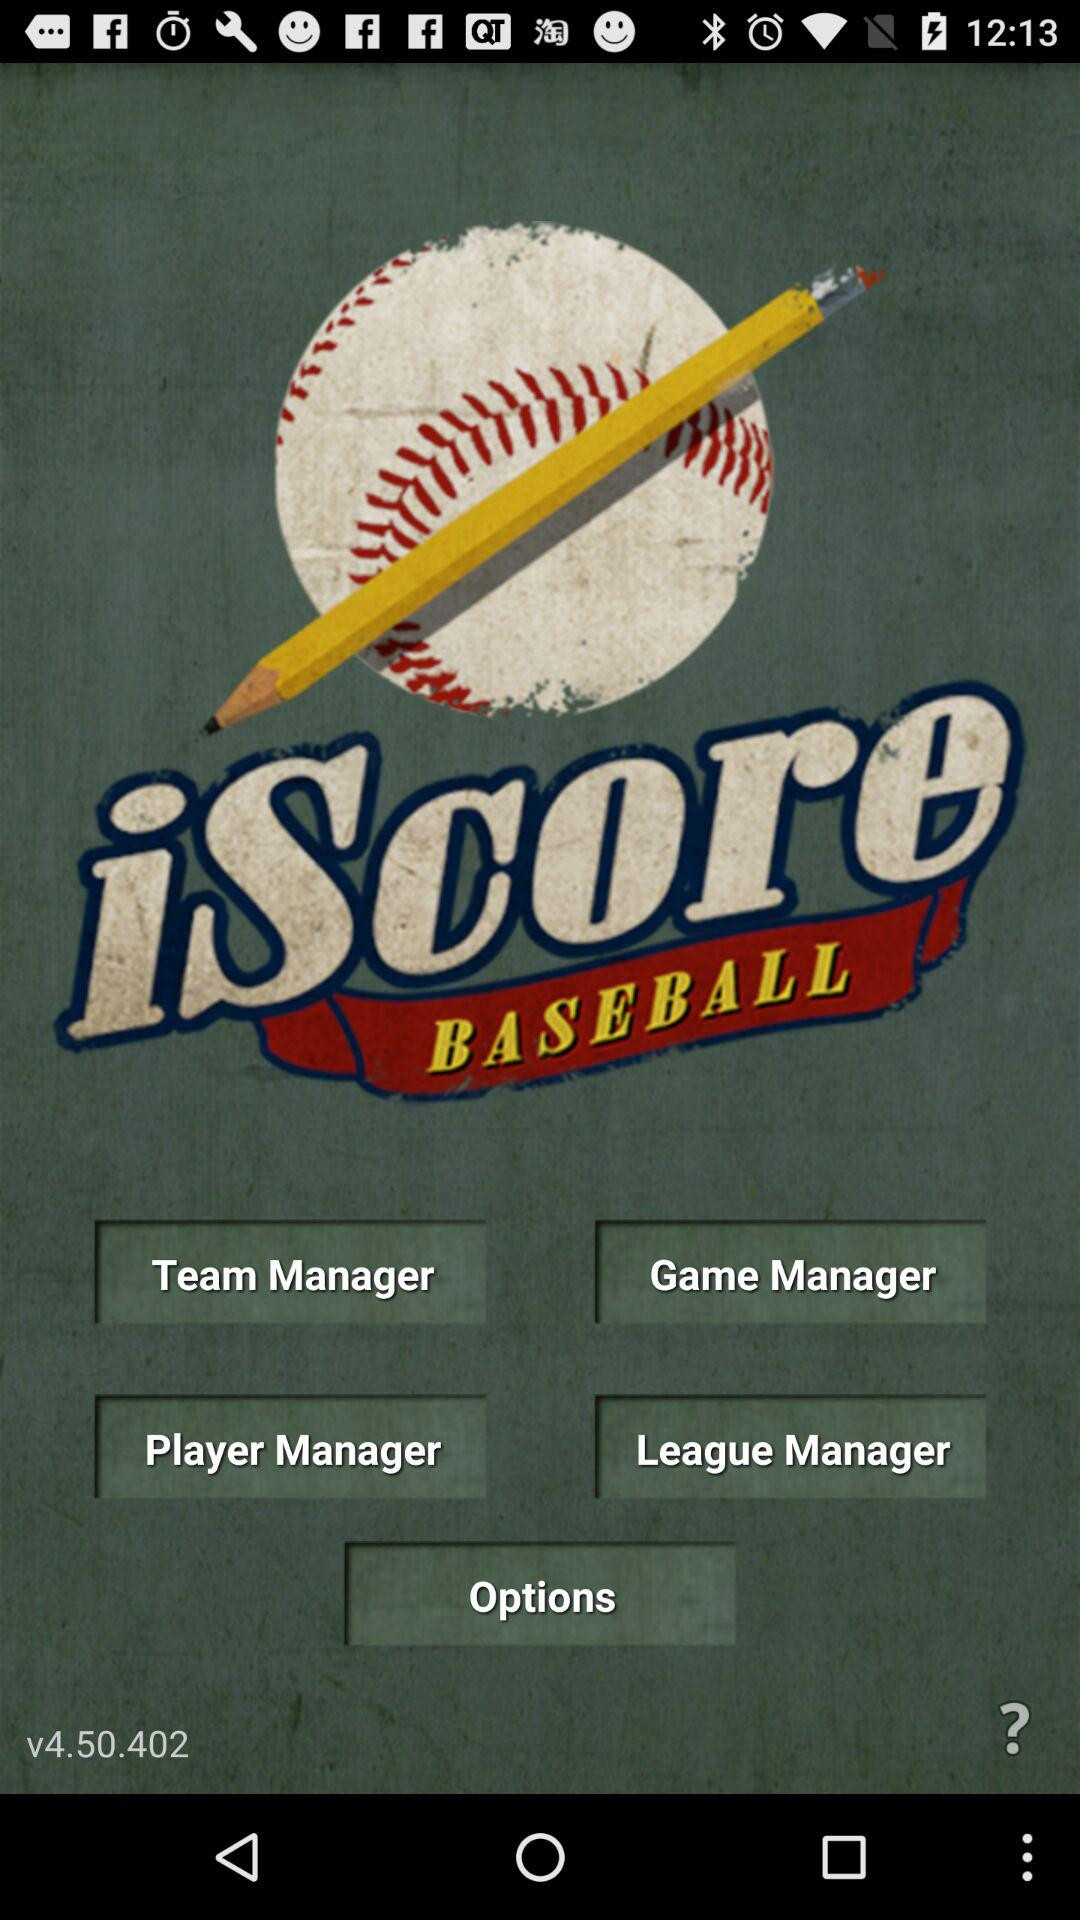What is the version of the application? The version of the application is v4.50.402. 